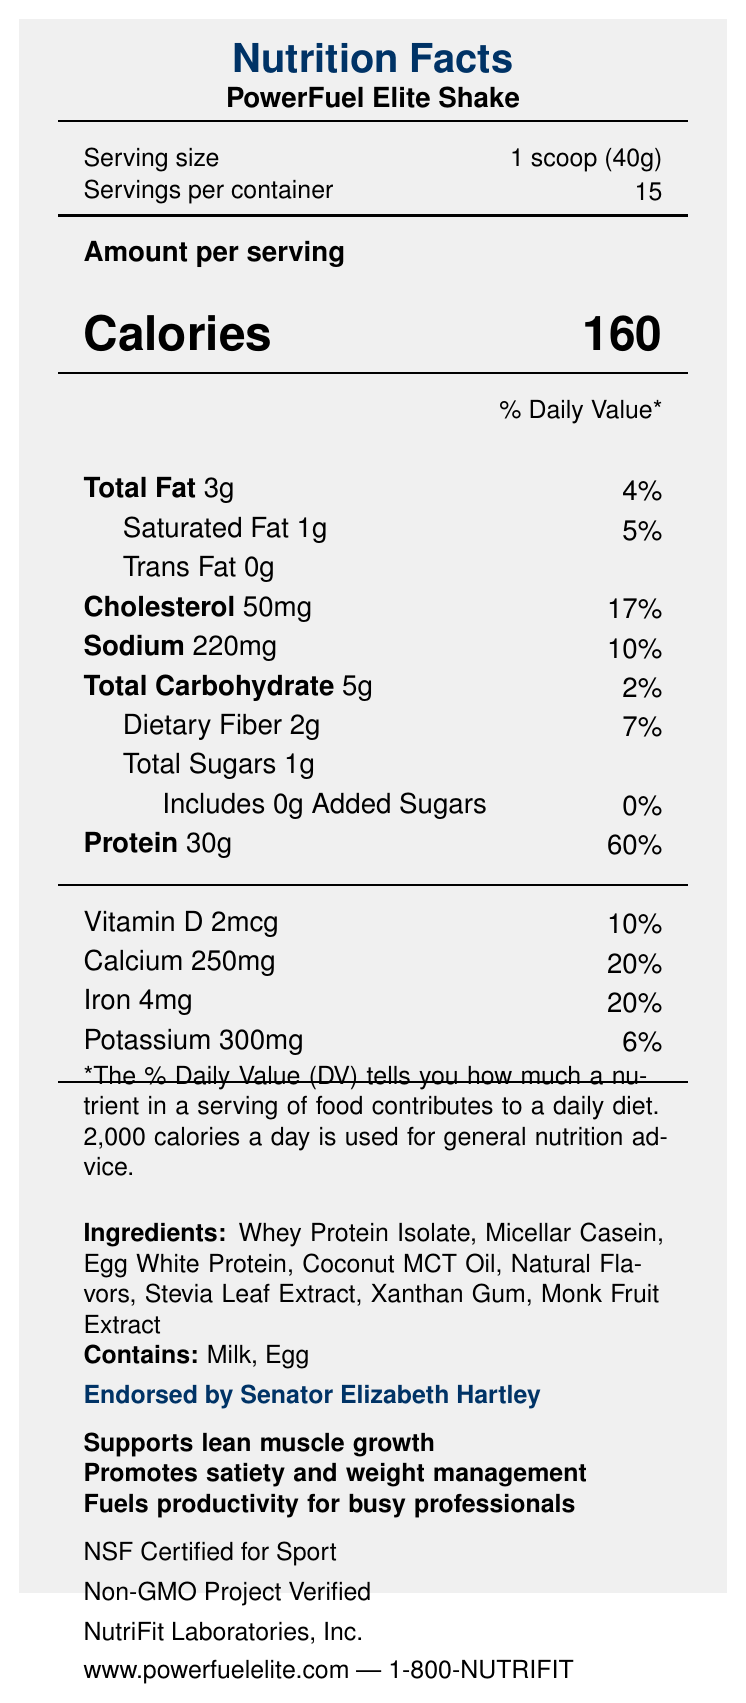what is the serving size of the PowerFuel Elite Shake? The serving size is mentioned next to the "Serving size" label as 1 scoop (40g).
Answer: 1 scoop (40g) how many servings are there per container? It is mentioned next to the "Servings per container" label as 15.
Answer: 15 how many calories are there per serving of PowerFuel Elite Shake? The "Calories" label states that there are 160 calories per serving.
Answer: 160 what percentage of the daily value for protein is provided by one serving? The "Protein" label shows that one serving provides 60% of the Daily Value.
Answer: 60% what is the total amount of fat in one serving? The "Total Fat" label states that there are 3g of total fat per serving.
Answer: 3g which nutrients have daily values of exactly 20%? A. Calcium and Iron B. Sodium and Iron C. Vitamin D and Calcium The Calcium label shows 20% and the Iron label also shows 20%.
Answer: A. Calcium and Iron how many grams of total carbohydrates are in one serving? The "Total Carbohydrate" label states that there are 5g of total carbohydrates per serving.
Answer: 5g does the PowerFuel Elite Shake contain any added sugars? The document specifies 0g of Added Sugars and 0% Daily Value.
Answer: No what allergens are present in this product? The "Contains" label states that the product contains Milk and Egg.
Answer: Milk, Egg is this product NSF Certified for Sport? The document mentions "NSF Certified for Sport".
Answer: Yes who endorses the PowerFuel Elite Shake? The document states that Senator Elizabeth Hartley endorses the product.
Answer: Senator Elizabeth Hartley summarize the key nutritional benefits and endorsements highlighted in the document. The provided document outlines the nutritional facts for the PowerFuel Elite Shake, including calorie content, fat, protein, carbohydrates, vitamins, and minerals. It highlights endorsements and certifications, marketing claims about the benefits, and contains allergen information.
Answer: The PowerFuel Elite Shake is a high-protein, low-carb meal replacement shake with 30g of protein per serving, low total carbohydrates (5g), low sugars (1g), and essential vitamins and minerals. It supports lean muscle growth, promotes satiety and weight management, and fuels productivity for busy professionals. It is endorsed by Senator Elizabeth Hartley and is both NSF Certified for Sport and Non-GMO Project Verified. can the exact amount of daily calories recommended be determined from this document? The document only mentions that the % Daily Value is based on a 2,000 calorie diet but does not provide further detail on recommended daily calorie intake.
Answer: No compare the percentage of daily value of cholesterol to that of sodium. Cholesterol has a higher daily value percentage (17%) compared to sodium (10%), as identified in the document.
Answer: Cholesterol 17%, Sodium 10% 